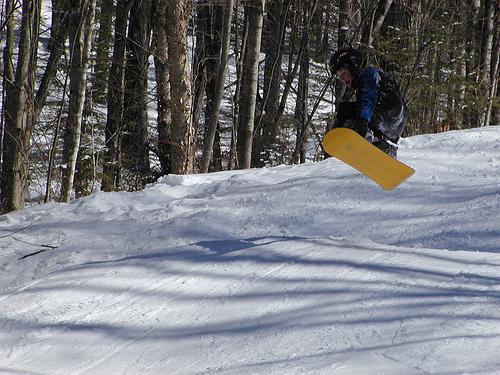What sport is the man playing?
Concise answer only. Snowboarding. What color is the snowboard?
Short answer required. Yellow. What does the person in the picture have in their hand?
Answer briefly. Snowboard. Is his snowboard on the ground?
Be succinct. No. Does this look like a recent picture?
Short answer required. Yes. Are those pine trees?
Answer briefly. No. Is there any shadows of plants in the image?
Keep it brief. Yes. 